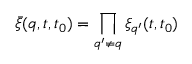<formula> <loc_0><loc_0><loc_500><loc_500>\bar { \xi } ( q , t , t _ { 0 } ) = \prod _ { q ^ { \prime } \neq q } \xi _ { q ^ { \prime } } ( t , t _ { 0 } )</formula> 